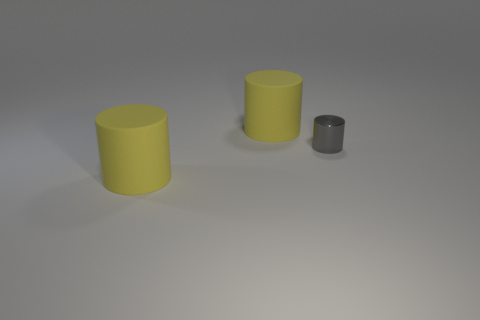Can you tell me the different sizes of cylinders in the image? Certainly! In the image, there appear to be two larger cylinders that seem to be identical in size and one smaller cylinder. The two larger ones could be described as big relative to the smaller one, which could be considered small or miniature by comparison. 